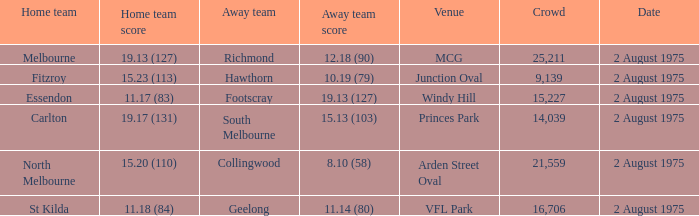When was a game played where the away team scored 10.19 (79)? 2 August 1975. Parse the table in full. {'header': ['Home team', 'Home team score', 'Away team', 'Away team score', 'Venue', 'Crowd', 'Date'], 'rows': [['Melbourne', '19.13 (127)', 'Richmond', '12.18 (90)', 'MCG', '25,211', '2 August 1975'], ['Fitzroy', '15.23 (113)', 'Hawthorn', '10.19 (79)', 'Junction Oval', '9,139', '2 August 1975'], ['Essendon', '11.17 (83)', 'Footscray', '19.13 (127)', 'Windy Hill', '15,227', '2 August 1975'], ['Carlton', '19.17 (131)', 'South Melbourne', '15.13 (103)', 'Princes Park', '14,039', '2 August 1975'], ['North Melbourne', '15.20 (110)', 'Collingwood', '8.10 (58)', 'Arden Street Oval', '21,559', '2 August 1975'], ['St Kilda', '11.18 (84)', 'Geelong', '11.14 (80)', 'VFL Park', '16,706', '2 August 1975']]} 